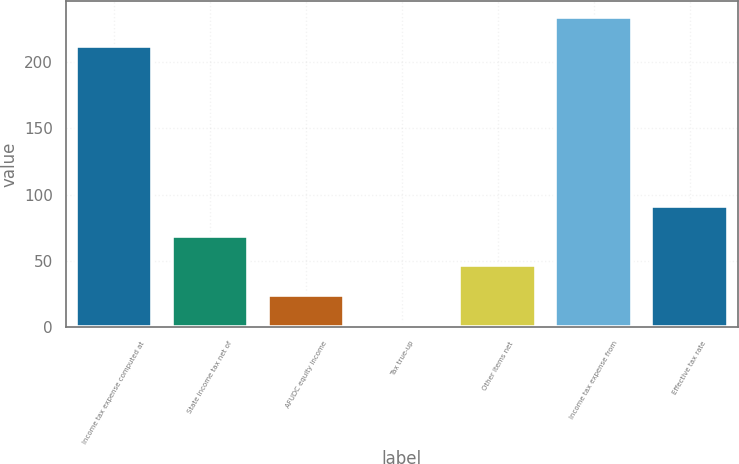Convert chart to OTSL. <chart><loc_0><loc_0><loc_500><loc_500><bar_chart><fcel>Income tax expense computed at<fcel>State income tax net of<fcel>AFUDC equity income<fcel>Tax true-up<fcel>Other items net<fcel>Income tax expense from<fcel>Effective tax rate<nl><fcel>212<fcel>68.9<fcel>24.3<fcel>2<fcel>46.6<fcel>234.3<fcel>91.2<nl></chart> 